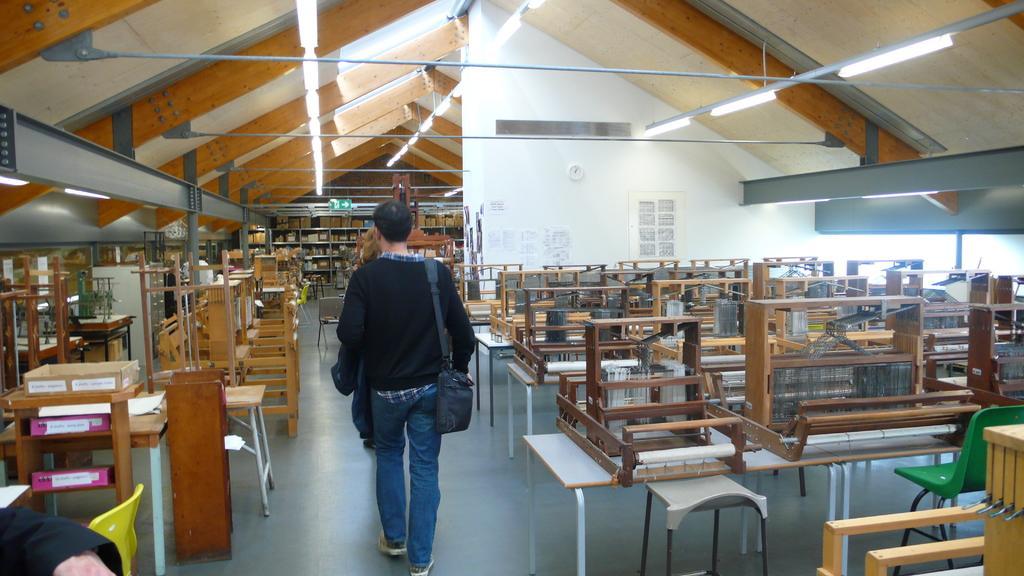Describe this image in one or two sentences. there is a man walking in a room where there are so many wooden things and wooden ceiling. 